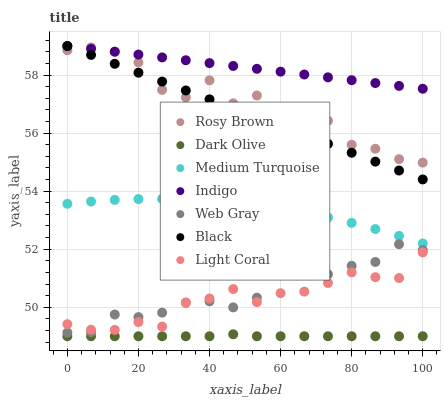Does Dark Olive have the minimum area under the curve?
Answer yes or no. Yes. Does Indigo have the maximum area under the curve?
Answer yes or no. Yes. Does Indigo have the minimum area under the curve?
Answer yes or no. No. Does Dark Olive have the maximum area under the curve?
Answer yes or no. No. Is Black the smoothest?
Answer yes or no. Yes. Is Rosy Brown the roughest?
Answer yes or no. Yes. Is Indigo the smoothest?
Answer yes or no. No. Is Indigo the roughest?
Answer yes or no. No. Does Dark Olive have the lowest value?
Answer yes or no. Yes. Does Indigo have the lowest value?
Answer yes or no. No. Does Black have the highest value?
Answer yes or no. Yes. Does Dark Olive have the highest value?
Answer yes or no. No. Is Light Coral less than Indigo?
Answer yes or no. Yes. Is Medium Turquoise greater than Light Coral?
Answer yes or no. Yes. Does Light Coral intersect Web Gray?
Answer yes or no. Yes. Is Light Coral less than Web Gray?
Answer yes or no. No. Is Light Coral greater than Web Gray?
Answer yes or no. No. Does Light Coral intersect Indigo?
Answer yes or no. No. 